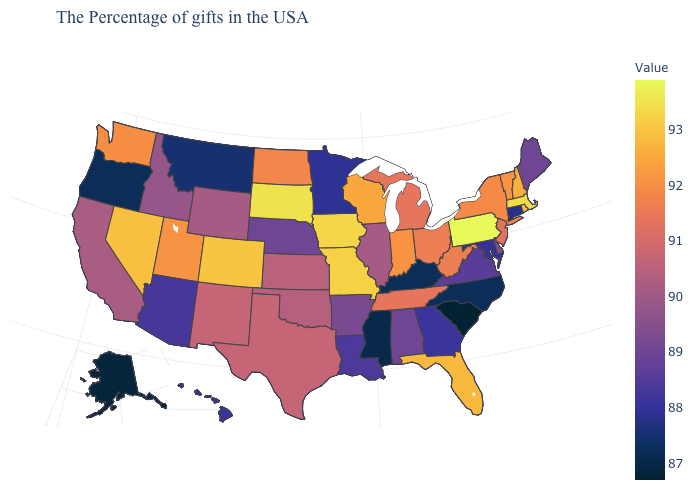Does Nebraska have a higher value than Oregon?
Give a very brief answer. Yes. Does Connecticut have a lower value than Mississippi?
Keep it brief. No. Is the legend a continuous bar?
Answer briefly. Yes. Does the map have missing data?
Concise answer only. No. 